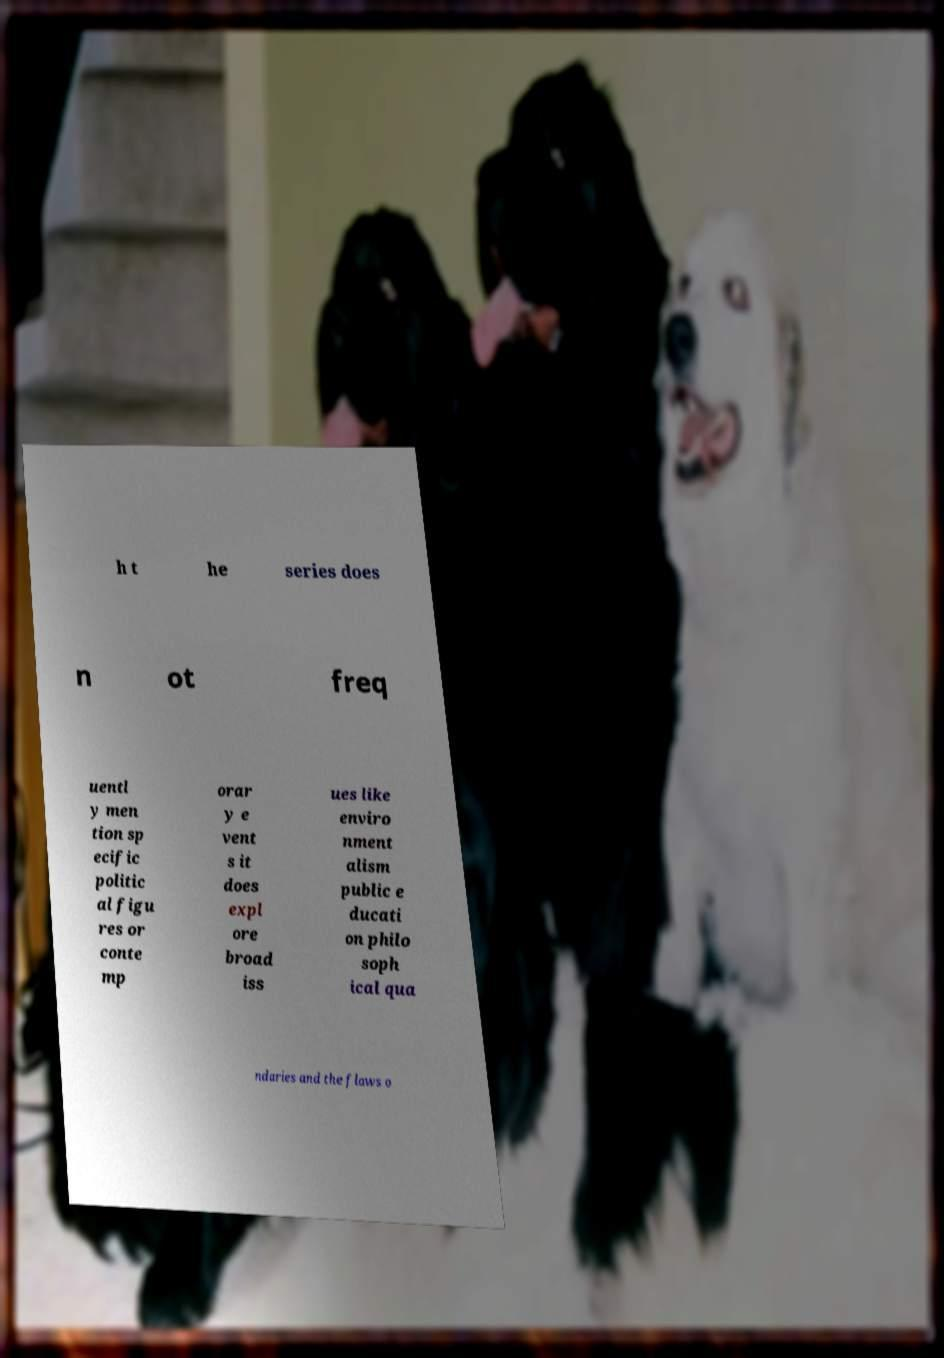What messages or text are displayed in this image? I need them in a readable, typed format. h t he series does n ot freq uentl y men tion sp ecific politic al figu res or conte mp orar y e vent s it does expl ore broad iss ues like enviro nment alism public e ducati on philo soph ical qua ndaries and the flaws o 